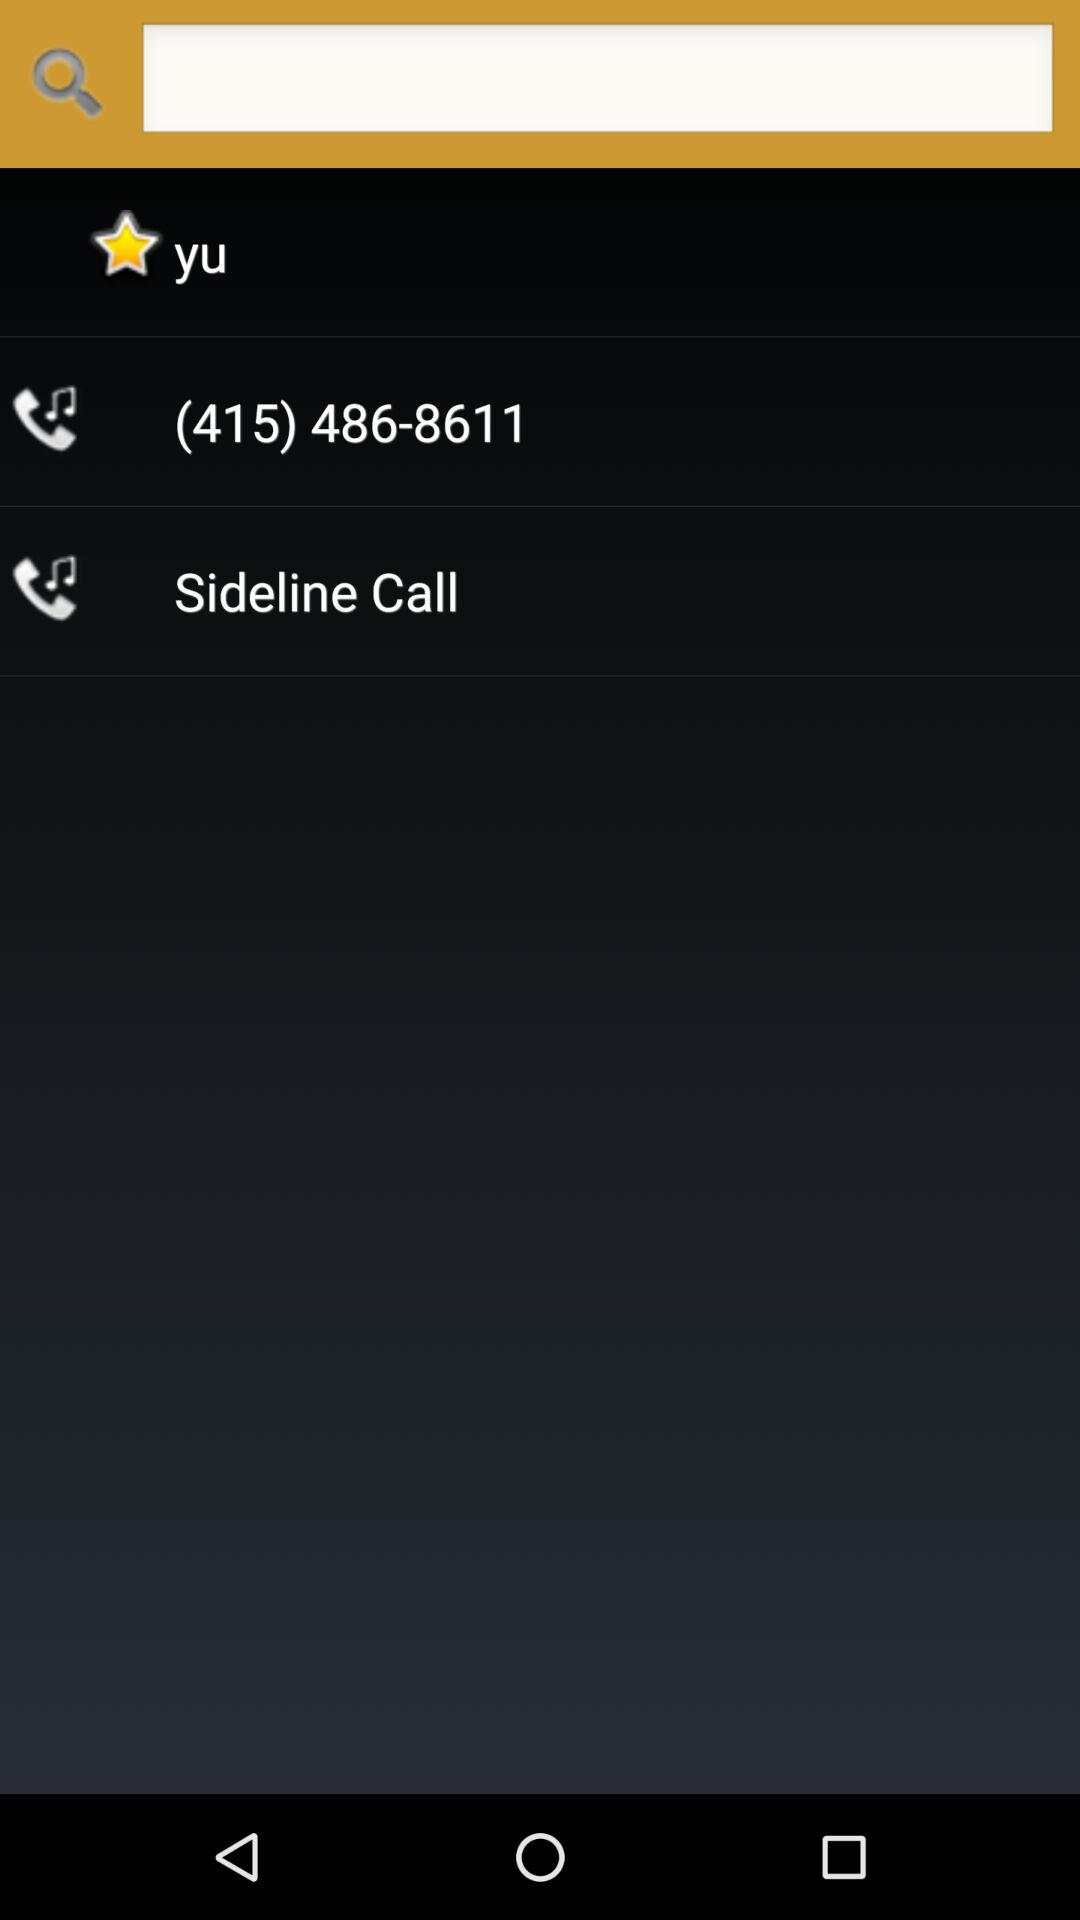What is the contact number? The contact number is (415) 486-8611. 